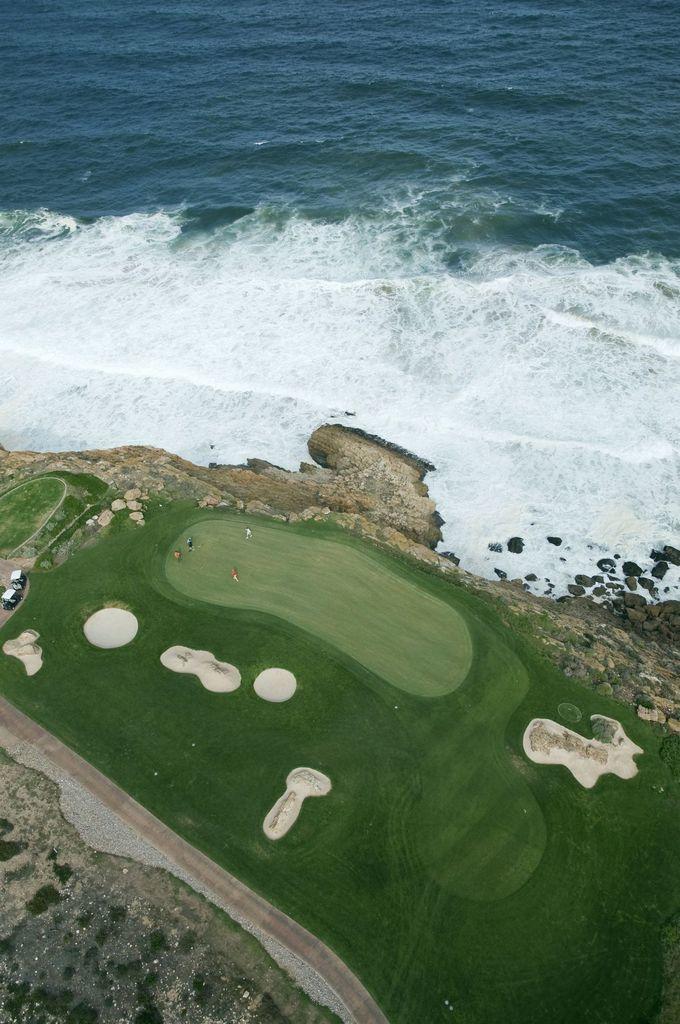Can you describe this image briefly? In the picture I can see the ocean. I can see the aerial photography and there are vehicles on the left side. 